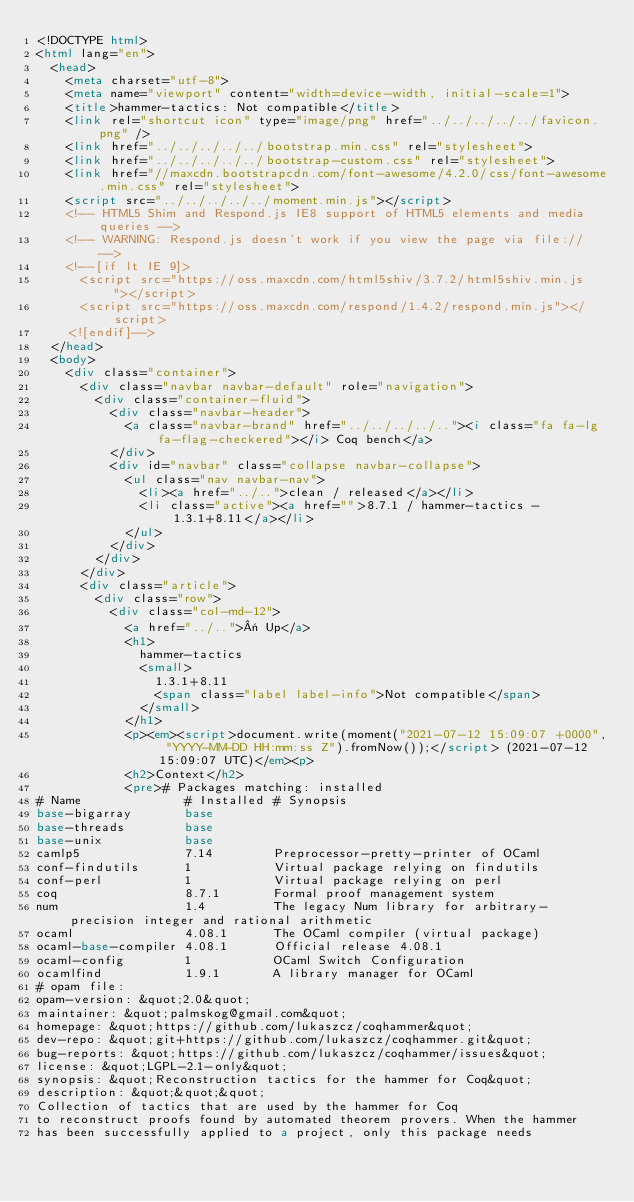Convert code to text. <code><loc_0><loc_0><loc_500><loc_500><_HTML_><!DOCTYPE html>
<html lang="en">
  <head>
    <meta charset="utf-8">
    <meta name="viewport" content="width=device-width, initial-scale=1">
    <title>hammer-tactics: Not compatible</title>
    <link rel="shortcut icon" type="image/png" href="../../../../../favicon.png" />
    <link href="../../../../../bootstrap.min.css" rel="stylesheet">
    <link href="../../../../../bootstrap-custom.css" rel="stylesheet">
    <link href="//maxcdn.bootstrapcdn.com/font-awesome/4.2.0/css/font-awesome.min.css" rel="stylesheet">
    <script src="../../../../../moment.min.js"></script>
    <!-- HTML5 Shim and Respond.js IE8 support of HTML5 elements and media queries -->
    <!-- WARNING: Respond.js doesn't work if you view the page via file:// -->
    <!--[if lt IE 9]>
      <script src="https://oss.maxcdn.com/html5shiv/3.7.2/html5shiv.min.js"></script>
      <script src="https://oss.maxcdn.com/respond/1.4.2/respond.min.js"></script>
    <![endif]-->
  </head>
  <body>
    <div class="container">
      <div class="navbar navbar-default" role="navigation">
        <div class="container-fluid">
          <div class="navbar-header">
            <a class="navbar-brand" href="../../../../.."><i class="fa fa-lg fa-flag-checkered"></i> Coq bench</a>
          </div>
          <div id="navbar" class="collapse navbar-collapse">
            <ul class="nav navbar-nav">
              <li><a href="../..">clean / released</a></li>
              <li class="active"><a href="">8.7.1 / hammer-tactics - 1.3.1+8.11</a></li>
            </ul>
          </div>
        </div>
      </div>
      <div class="article">
        <div class="row">
          <div class="col-md-12">
            <a href="../..">« Up</a>
            <h1>
              hammer-tactics
              <small>
                1.3.1+8.11
                <span class="label label-info">Not compatible</span>
              </small>
            </h1>
            <p><em><script>document.write(moment("2021-07-12 15:09:07 +0000", "YYYY-MM-DD HH:mm:ss Z").fromNow());</script> (2021-07-12 15:09:07 UTC)</em><p>
            <h2>Context</h2>
            <pre># Packages matching: installed
# Name              # Installed # Synopsis
base-bigarray       base
base-threads        base
base-unix           base
camlp5              7.14        Preprocessor-pretty-printer of OCaml
conf-findutils      1           Virtual package relying on findutils
conf-perl           1           Virtual package relying on perl
coq                 8.7.1       Formal proof management system
num                 1.4         The legacy Num library for arbitrary-precision integer and rational arithmetic
ocaml               4.08.1      The OCaml compiler (virtual package)
ocaml-base-compiler 4.08.1      Official release 4.08.1
ocaml-config        1           OCaml Switch Configuration
ocamlfind           1.9.1       A library manager for OCaml
# opam file:
opam-version: &quot;2.0&quot;
maintainer: &quot;palmskog@gmail.com&quot;
homepage: &quot;https://github.com/lukaszcz/coqhammer&quot;
dev-repo: &quot;git+https://github.com/lukaszcz/coqhammer.git&quot;
bug-reports: &quot;https://github.com/lukaszcz/coqhammer/issues&quot;
license: &quot;LGPL-2.1-only&quot;
synopsis: &quot;Reconstruction tactics for the hammer for Coq&quot;
description: &quot;&quot;&quot;
Collection of tactics that are used by the hammer for Coq
to reconstruct proofs found by automated theorem provers. When the hammer
has been successfully applied to a project, only this package needs</code> 